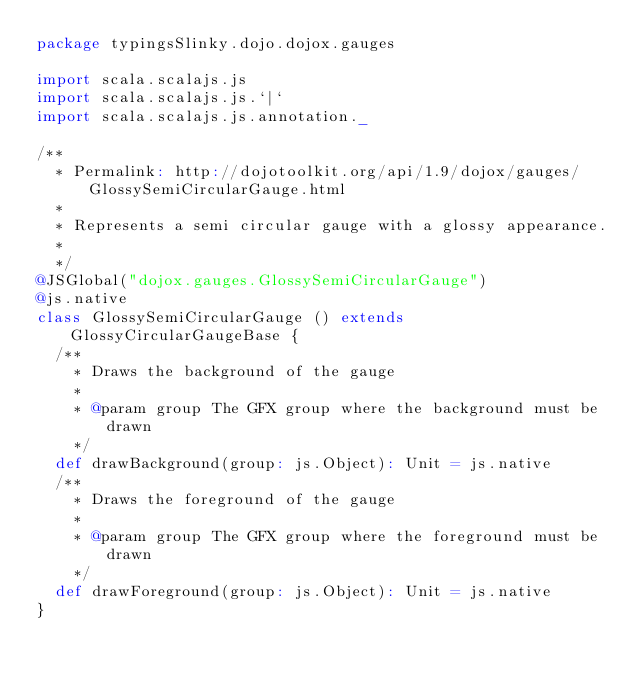<code> <loc_0><loc_0><loc_500><loc_500><_Scala_>package typingsSlinky.dojo.dojox.gauges

import scala.scalajs.js
import scala.scalajs.js.`|`
import scala.scalajs.js.annotation._

/**
  * Permalink: http://dojotoolkit.org/api/1.9/dojox/gauges/GlossySemiCircularGauge.html
  *
  * Represents a semi circular gauge with a glossy appearance.
  *
  */
@JSGlobal("dojox.gauges.GlossySemiCircularGauge")
@js.native
class GlossySemiCircularGauge () extends GlossyCircularGaugeBase {
  /**
    * Draws the background of the gauge
    *
    * @param group The GFX group where the background must be drawn
    */
  def drawBackground(group: js.Object): Unit = js.native
  /**
    * Draws the foreground of the gauge
    *
    * @param group The GFX group where the foreground must be drawn
    */
  def drawForeground(group: js.Object): Unit = js.native
}

</code> 